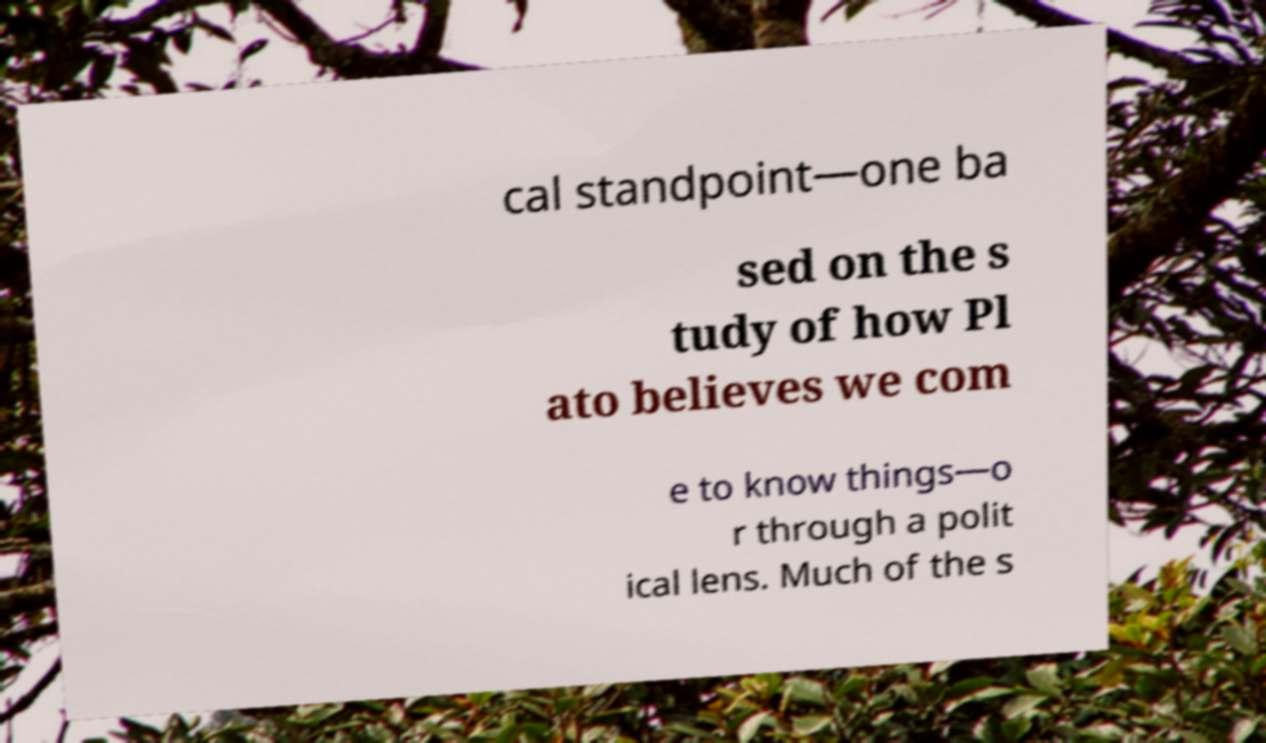For documentation purposes, I need the text within this image transcribed. Could you provide that? cal standpoint—one ba sed on the s tudy of how Pl ato believes we com e to know things—o r through a polit ical lens. Much of the s 